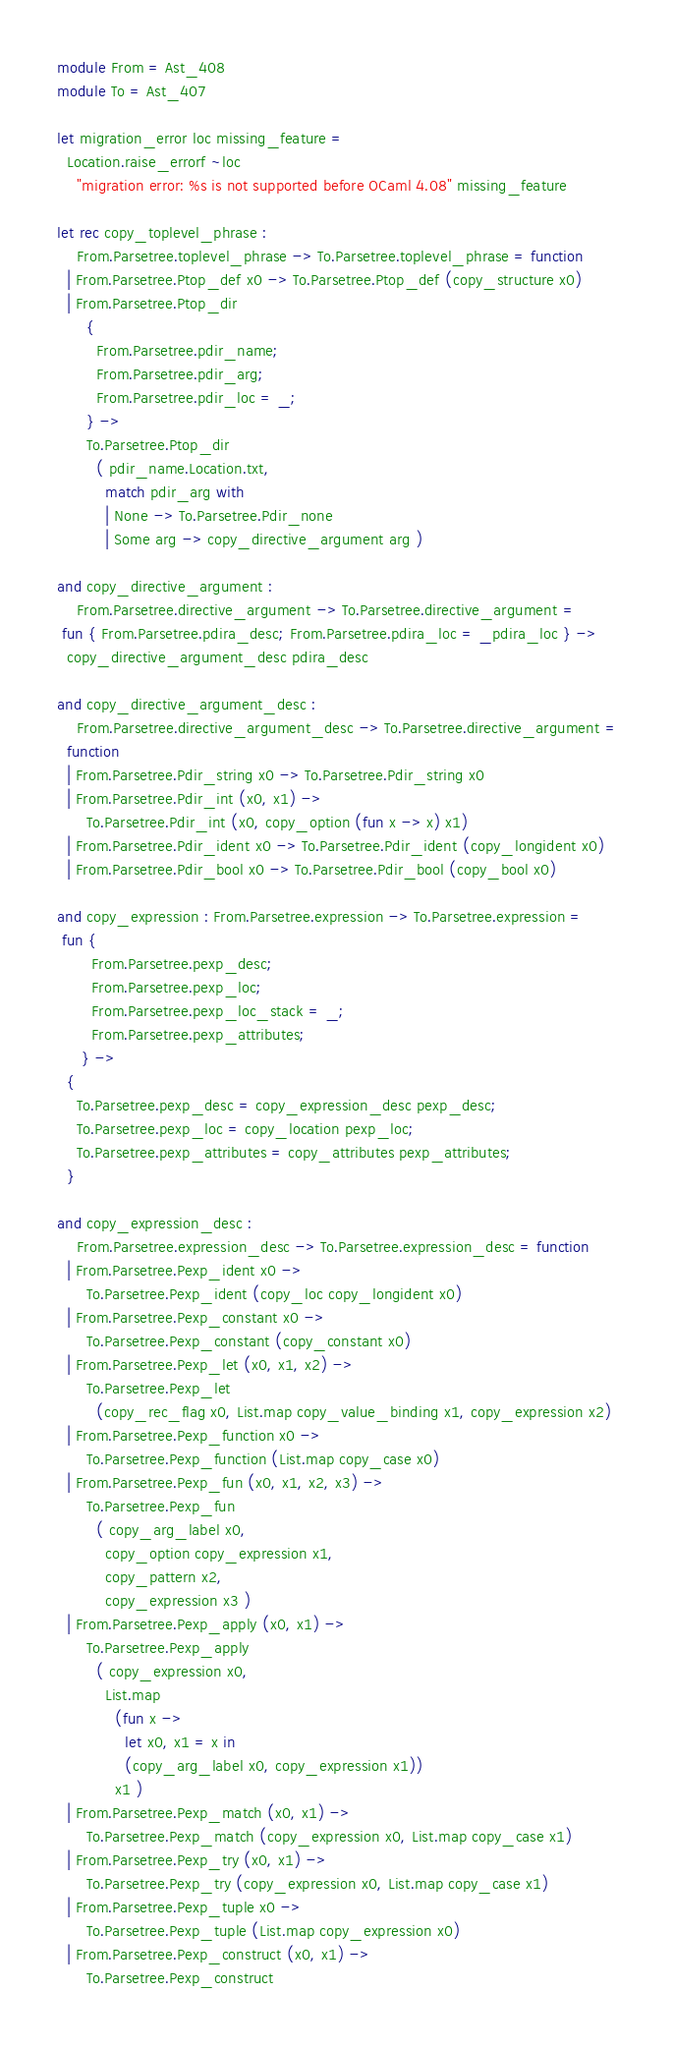Convert code to text. <code><loc_0><loc_0><loc_500><loc_500><_OCaml_>module From = Ast_408
module To = Ast_407

let migration_error loc missing_feature =
  Location.raise_errorf ~loc
    "migration error: %s is not supported before OCaml 4.08" missing_feature

let rec copy_toplevel_phrase :
    From.Parsetree.toplevel_phrase -> To.Parsetree.toplevel_phrase = function
  | From.Parsetree.Ptop_def x0 -> To.Parsetree.Ptop_def (copy_structure x0)
  | From.Parsetree.Ptop_dir
      {
        From.Parsetree.pdir_name;
        From.Parsetree.pdir_arg;
        From.Parsetree.pdir_loc = _;
      } ->
      To.Parsetree.Ptop_dir
        ( pdir_name.Location.txt,
          match pdir_arg with
          | None -> To.Parsetree.Pdir_none
          | Some arg -> copy_directive_argument arg )

and copy_directive_argument :
    From.Parsetree.directive_argument -> To.Parsetree.directive_argument =
 fun { From.Parsetree.pdira_desc; From.Parsetree.pdira_loc = _pdira_loc } ->
  copy_directive_argument_desc pdira_desc

and copy_directive_argument_desc :
    From.Parsetree.directive_argument_desc -> To.Parsetree.directive_argument =
  function
  | From.Parsetree.Pdir_string x0 -> To.Parsetree.Pdir_string x0
  | From.Parsetree.Pdir_int (x0, x1) ->
      To.Parsetree.Pdir_int (x0, copy_option (fun x -> x) x1)
  | From.Parsetree.Pdir_ident x0 -> To.Parsetree.Pdir_ident (copy_longident x0)
  | From.Parsetree.Pdir_bool x0 -> To.Parsetree.Pdir_bool (copy_bool x0)

and copy_expression : From.Parsetree.expression -> To.Parsetree.expression =
 fun {
       From.Parsetree.pexp_desc;
       From.Parsetree.pexp_loc;
       From.Parsetree.pexp_loc_stack = _;
       From.Parsetree.pexp_attributes;
     } ->
  {
    To.Parsetree.pexp_desc = copy_expression_desc pexp_desc;
    To.Parsetree.pexp_loc = copy_location pexp_loc;
    To.Parsetree.pexp_attributes = copy_attributes pexp_attributes;
  }

and copy_expression_desc :
    From.Parsetree.expression_desc -> To.Parsetree.expression_desc = function
  | From.Parsetree.Pexp_ident x0 ->
      To.Parsetree.Pexp_ident (copy_loc copy_longident x0)
  | From.Parsetree.Pexp_constant x0 ->
      To.Parsetree.Pexp_constant (copy_constant x0)
  | From.Parsetree.Pexp_let (x0, x1, x2) ->
      To.Parsetree.Pexp_let
        (copy_rec_flag x0, List.map copy_value_binding x1, copy_expression x2)
  | From.Parsetree.Pexp_function x0 ->
      To.Parsetree.Pexp_function (List.map copy_case x0)
  | From.Parsetree.Pexp_fun (x0, x1, x2, x3) ->
      To.Parsetree.Pexp_fun
        ( copy_arg_label x0,
          copy_option copy_expression x1,
          copy_pattern x2,
          copy_expression x3 )
  | From.Parsetree.Pexp_apply (x0, x1) ->
      To.Parsetree.Pexp_apply
        ( copy_expression x0,
          List.map
            (fun x ->
              let x0, x1 = x in
              (copy_arg_label x0, copy_expression x1))
            x1 )
  | From.Parsetree.Pexp_match (x0, x1) ->
      To.Parsetree.Pexp_match (copy_expression x0, List.map copy_case x1)
  | From.Parsetree.Pexp_try (x0, x1) ->
      To.Parsetree.Pexp_try (copy_expression x0, List.map copy_case x1)
  | From.Parsetree.Pexp_tuple x0 ->
      To.Parsetree.Pexp_tuple (List.map copy_expression x0)
  | From.Parsetree.Pexp_construct (x0, x1) ->
      To.Parsetree.Pexp_construct</code> 